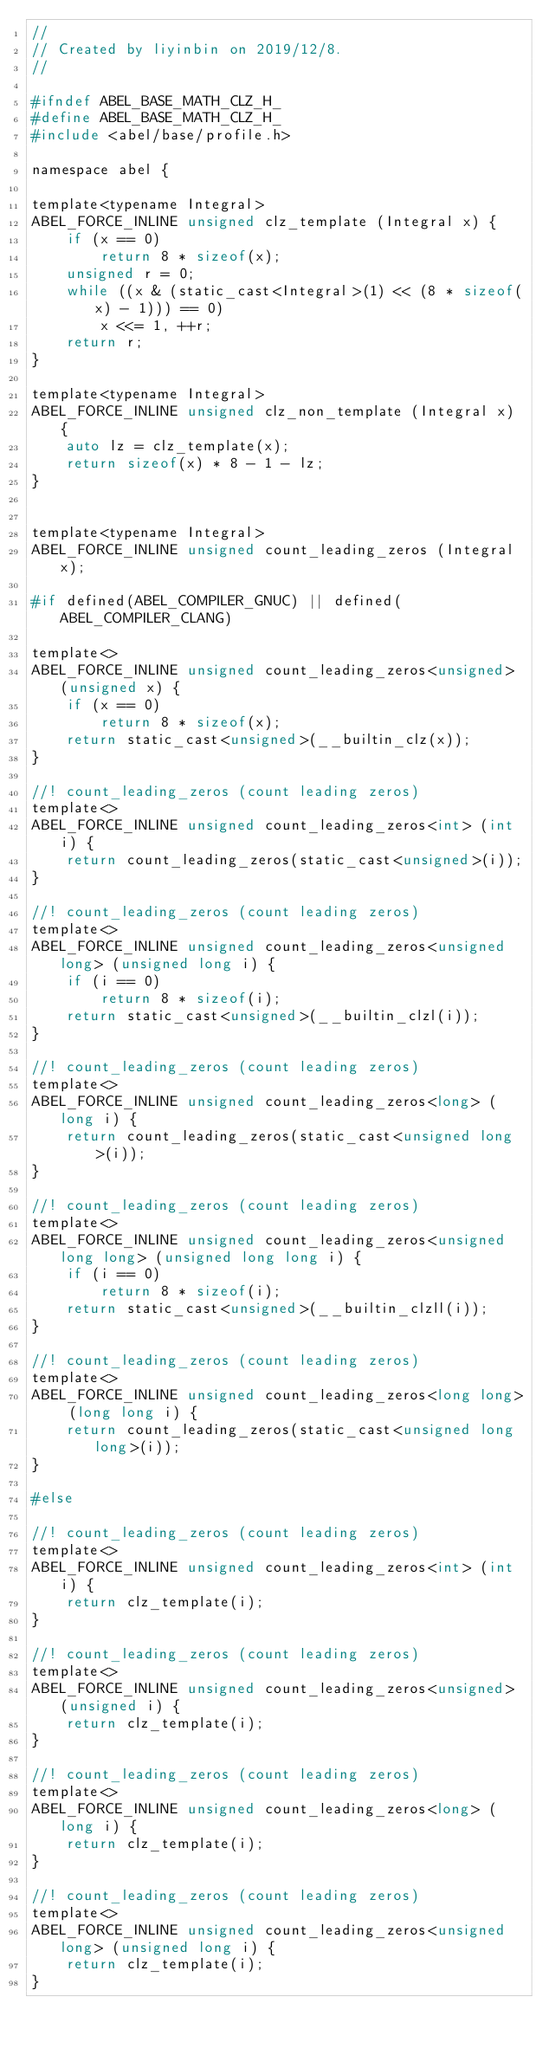<code> <loc_0><loc_0><loc_500><loc_500><_C_>//
// Created by liyinbin on 2019/12/8.
//

#ifndef ABEL_BASE_MATH_CLZ_H_
#define ABEL_BASE_MATH_CLZ_H_
#include <abel/base/profile.h>

namespace abel {

template<typename Integral>
ABEL_FORCE_INLINE unsigned clz_template (Integral x) {
    if (x == 0)
        return 8 * sizeof(x);
    unsigned r = 0;
    while ((x & (static_cast<Integral>(1) << (8 * sizeof(x) - 1))) == 0)
        x <<= 1, ++r;
    return r;
}

template<typename Integral>
ABEL_FORCE_INLINE unsigned clz_non_template (Integral x) {
    auto lz = clz_template(x);
    return sizeof(x) * 8 - 1 - lz;
}


template<typename Integral>
ABEL_FORCE_INLINE unsigned count_leading_zeros (Integral x);

#if defined(ABEL_COMPILER_GNUC) || defined(ABEL_COMPILER_CLANG)

template<>
ABEL_FORCE_INLINE unsigned count_leading_zeros<unsigned> (unsigned x) {
    if (x == 0)
        return 8 * sizeof(x);
    return static_cast<unsigned>(__builtin_clz(x));
}

//! count_leading_zeros (count leading zeros)
template<>
ABEL_FORCE_INLINE unsigned count_leading_zeros<int> (int i) {
    return count_leading_zeros(static_cast<unsigned>(i));
}

//! count_leading_zeros (count leading zeros)
template<>
ABEL_FORCE_INLINE unsigned count_leading_zeros<unsigned long> (unsigned long i) {
    if (i == 0)
        return 8 * sizeof(i);
    return static_cast<unsigned>(__builtin_clzl(i));
}

//! count_leading_zeros (count leading zeros)
template<>
ABEL_FORCE_INLINE unsigned count_leading_zeros<long> (long i) {
    return count_leading_zeros(static_cast<unsigned long>(i));
}

//! count_leading_zeros (count leading zeros)
template<>
ABEL_FORCE_INLINE unsigned count_leading_zeros<unsigned long long> (unsigned long long i) {
    if (i == 0)
        return 8 * sizeof(i);
    return static_cast<unsigned>(__builtin_clzll(i));
}

//! count_leading_zeros (count leading zeros)
template<>
ABEL_FORCE_INLINE unsigned count_leading_zeros<long long> (long long i) {
    return count_leading_zeros(static_cast<unsigned long long>(i));
}

#else

//! count_leading_zeros (count leading zeros)
template<>
ABEL_FORCE_INLINE unsigned count_leading_zeros<int> (int i) {
    return clz_template(i);
}

//! count_leading_zeros (count leading zeros)
template<>
ABEL_FORCE_INLINE unsigned count_leading_zeros<unsigned> (unsigned i) {
    return clz_template(i);
}

//! count_leading_zeros (count leading zeros)
template<>
ABEL_FORCE_INLINE unsigned count_leading_zeros<long> (long i) {
    return clz_template(i);
}

//! count_leading_zeros (count leading zeros)
template<>
ABEL_FORCE_INLINE unsigned count_leading_zeros<unsigned long> (unsigned long i) {
    return clz_template(i);
}
</code> 